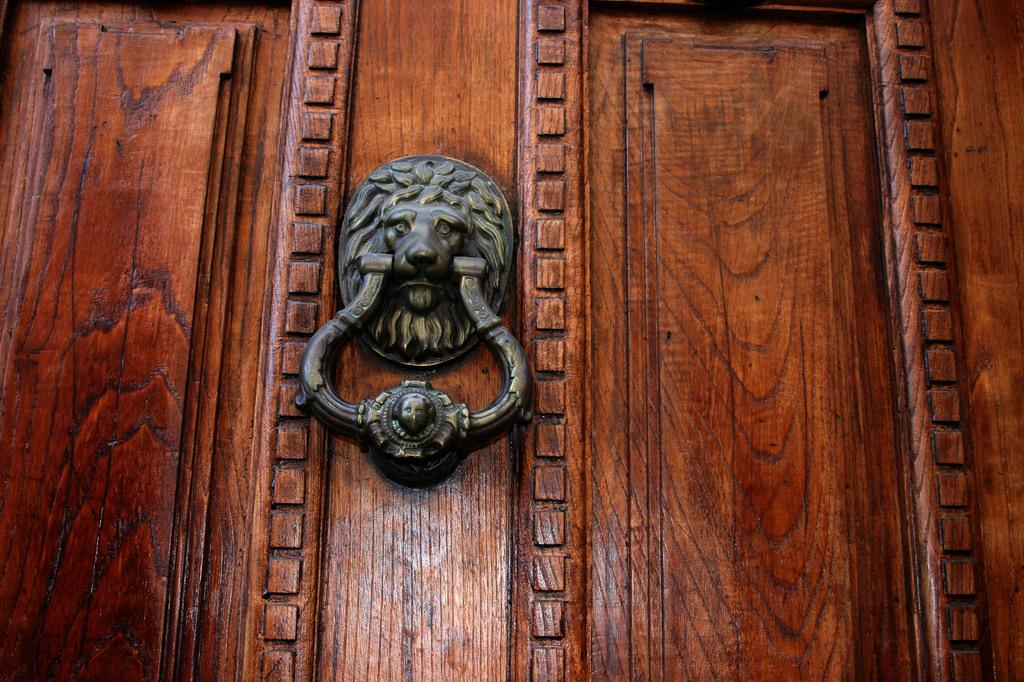What is the shape of the door handle in the image? The door handle is shaped like a lion head. What is the color or tone of the door handle? The door handle has a copper tone. Is the door handle attached to anything? Yes, the door handle is attached to a door. Can the lion head door handle bite someone in the image? No, the door handle is not capable of biting someone, as it is an inanimate object. 